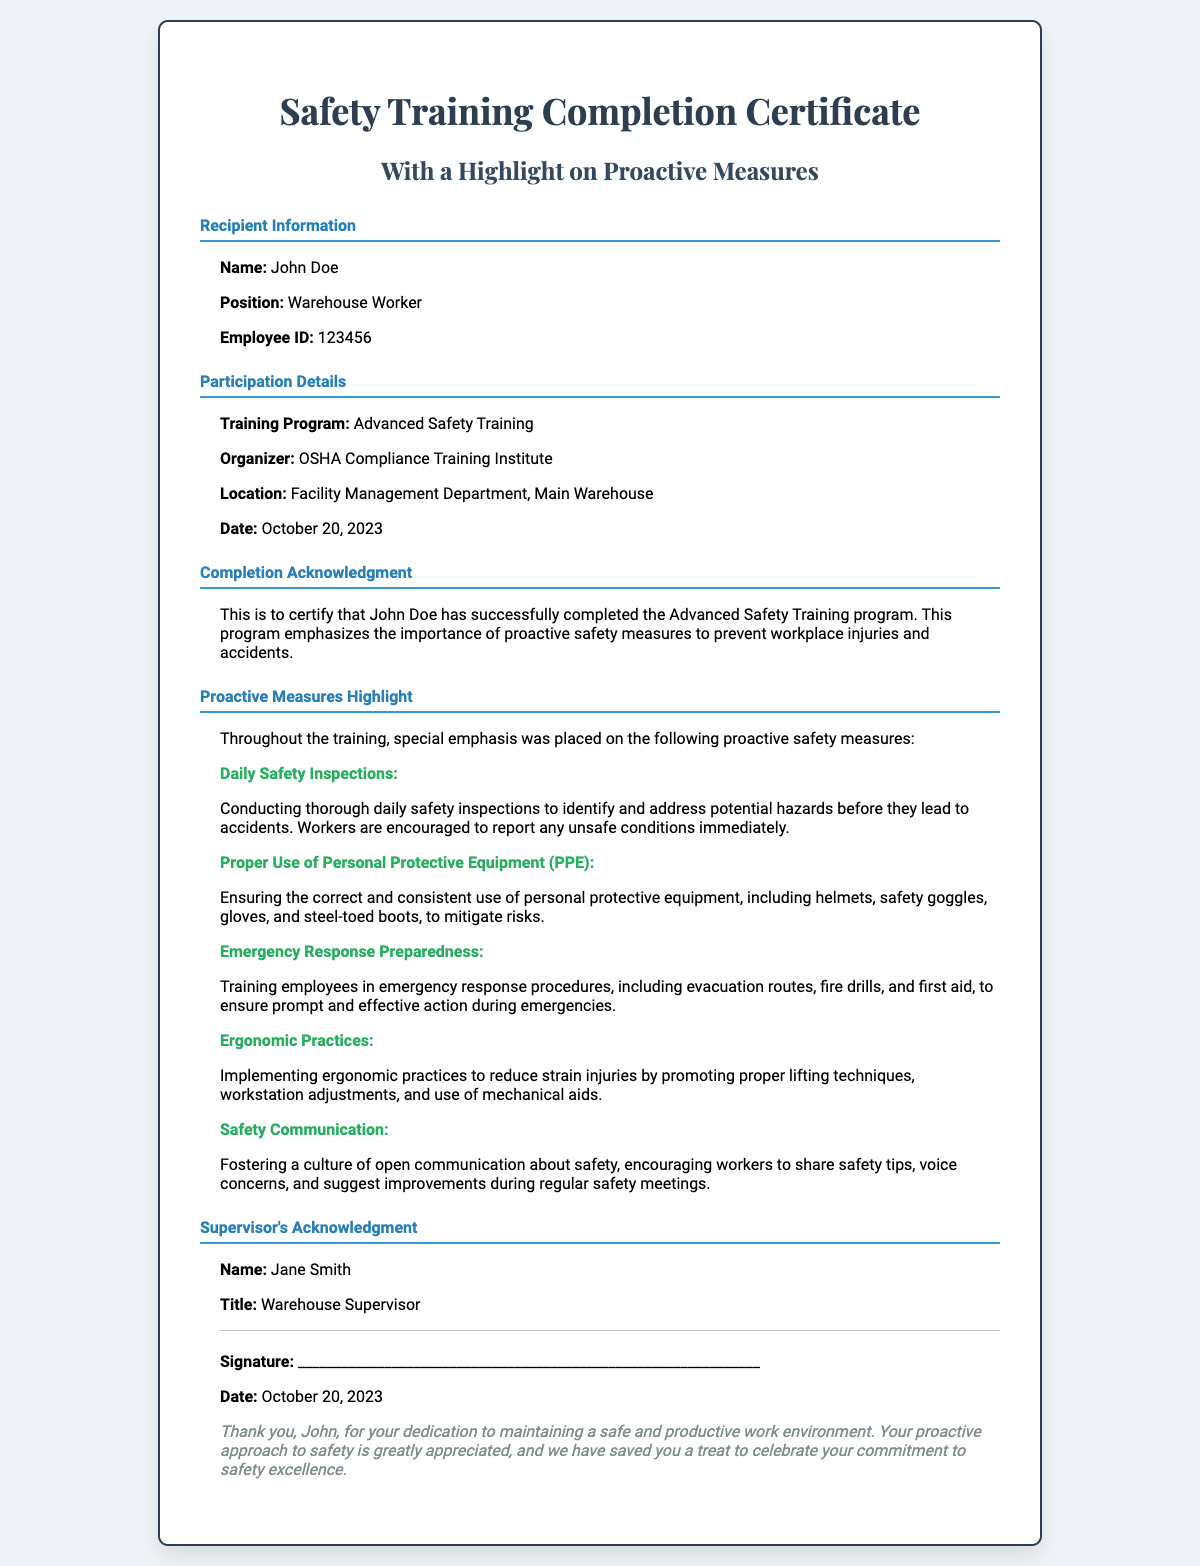What is the recipient's name? The document states the recipient's name is John Doe.
Answer: John Doe What is the date of the training? The certificate mentions the training date as October 20, 2023.
Answer: October 20, 2023 Who organized the training program? The organizer of the training program is referenced in the certificate as OSHA Compliance Training Institute.
Answer: OSHA Compliance Training Institute What is the position of the recipient? The document specifies that the recipient holds the position of Warehouse Worker.
Answer: Warehouse Worker What is one of the proactive measures highlighted? There are various proactive measures listed, such as Daily Safety Inspections, providing emphasis on safety responsibilities of workers.
Answer: Daily Safety Inspections How many proactive measures are highlighted in the document? The certificate enumerates five specific proactive measures throughout the training session.
Answer: Five What is the title of the supervisor? The supervisor's title is mentioned as Warehouse Supervisor in the acknowledgment section.
Answer: Warehouse Supervisor What is included in the signature line? The document provides a placeholder for the supervisor's signature to validate the training completion.
Answer: Signature What is the note at the end of the certificate about? The note expresses gratitude towards the recipient for their commitment to safety and mentions saving a treat for them.
Answer: Saving a treat for celebration 